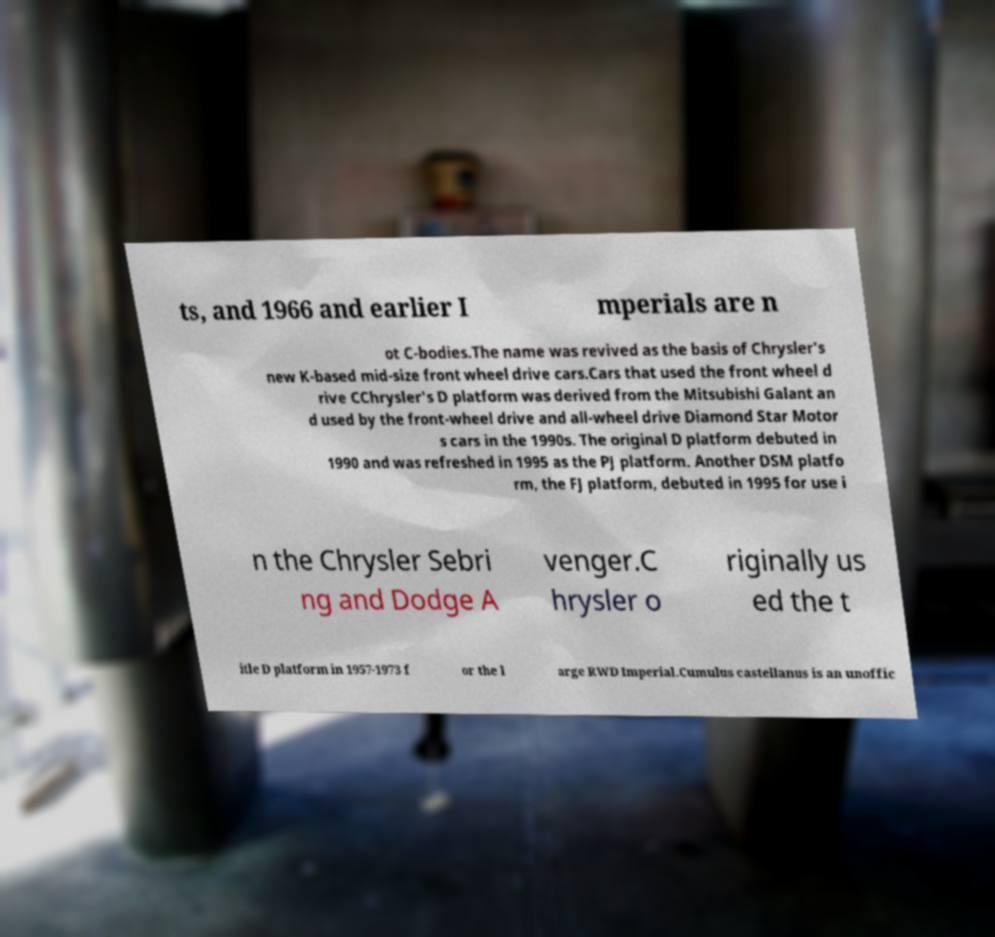Please read and relay the text visible in this image. What does it say? ts, and 1966 and earlier I mperials are n ot C-bodies.The name was revived as the basis of Chrysler's new K-based mid-size front wheel drive cars.Cars that used the front wheel d rive CChrysler's D platform was derived from the Mitsubishi Galant an d used by the front-wheel drive and all-wheel drive Diamond Star Motor s cars in the 1990s. The original D platform debuted in 1990 and was refreshed in 1995 as the PJ platform. Another DSM platfo rm, the FJ platform, debuted in 1995 for use i n the Chrysler Sebri ng and Dodge A venger.C hrysler o riginally us ed the t itle D platform in 1957-1973 f or the l arge RWD Imperial.Cumulus castellanus is an unoffic 